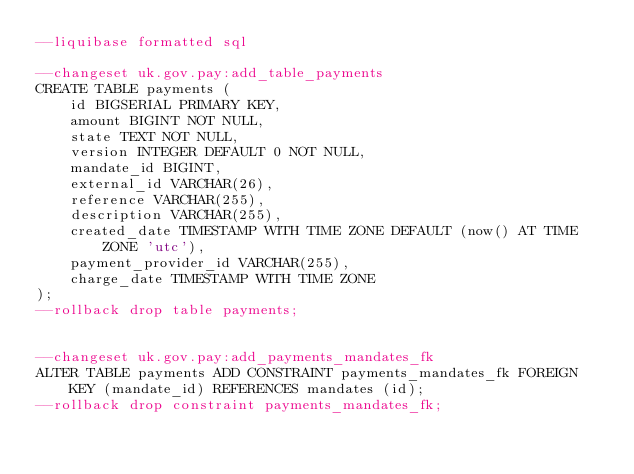<code> <loc_0><loc_0><loc_500><loc_500><_SQL_>--liquibase formatted sql

--changeset uk.gov.pay:add_table_payments
CREATE TABLE payments (
    id BIGSERIAL PRIMARY KEY,
    amount BIGINT NOT NULL,
    state TEXT NOT NULL,
    version INTEGER DEFAULT 0 NOT NULL,
    mandate_id BIGINT,
    external_id VARCHAR(26),
    reference VARCHAR(255),
    description VARCHAR(255),
    created_date TIMESTAMP WITH TIME ZONE DEFAULT (now() AT TIME ZONE 'utc'),
    payment_provider_id VARCHAR(255),
    charge_date TIMESTAMP WITH TIME ZONE
);
--rollback drop table payments;


--changeset uk.gov.pay:add_payments_mandates_fk
ALTER TABLE payments ADD CONSTRAINT payments_mandates_fk FOREIGN KEY (mandate_id) REFERENCES mandates (id);
--rollback drop constraint payments_mandates_fk;
</code> 